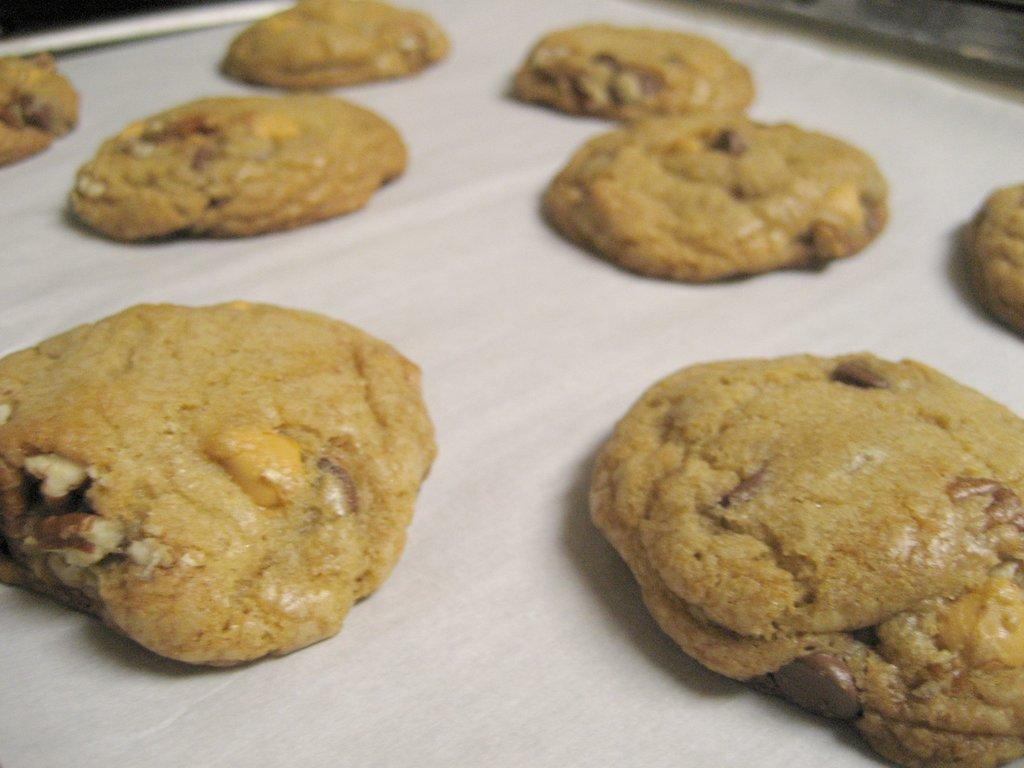What type of food is visible in the image? There are doughnuts in the image. Where are the doughnuts placed? The doughnuts are placed on a white sheet. What type of insurance is required for the doughnuts in the image? There is no mention of insurance in the image, and doughnuts do not require insurance. 